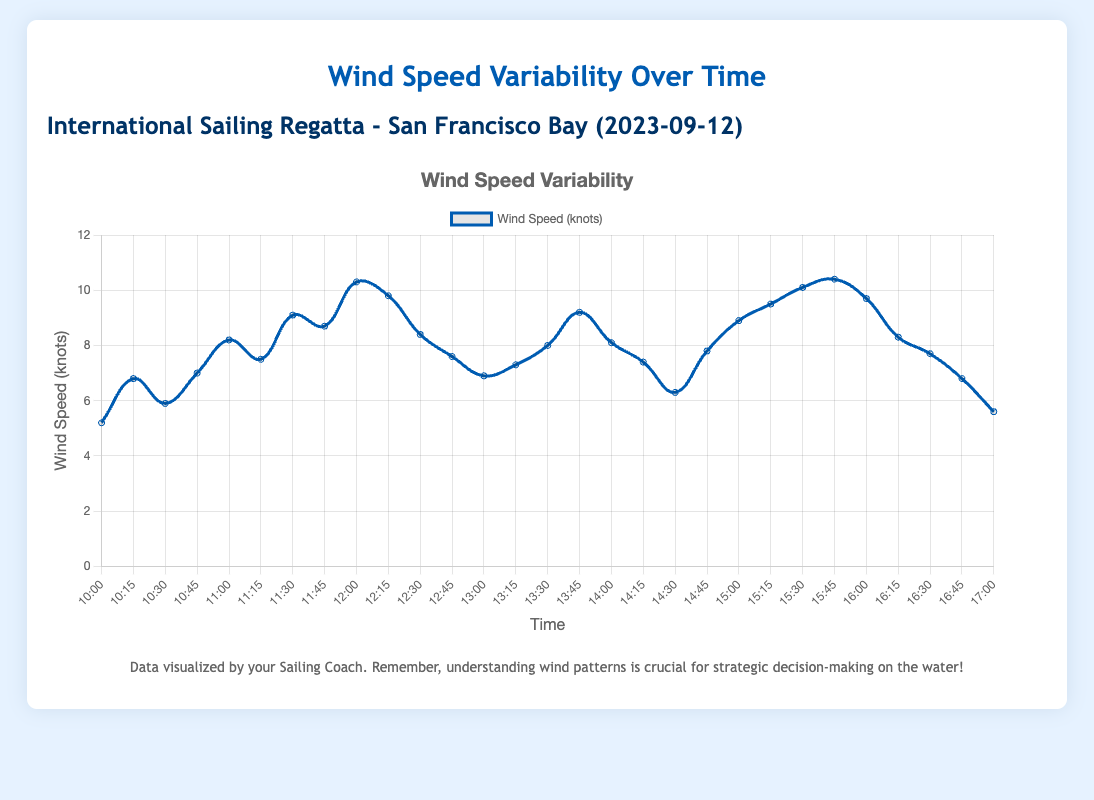What is the average wind speed between 14:00 and 15:00? To find the average wind speed between 14:00 and 15:00, add the wind speeds at 14:00, 14:15, 14:30, 14:45, and 15:00, then divide by the number of measurements. (8.1 + 7.4 + 6.3 + 7.8 + 8.9) / 5 = 38.5 / 5 = 7.7 knots
Answer: 7.7 knots At what time did the wind speed peak, and what was the value? Inspect the plot and identify the highest data point. The peak wind speed occurred at 15:45 with a value of 10.4 knots.
Answer: 15:45, 10.4 knots Which 30-minute interval showed the highest increase in wind speed? Look at consecutive 30-minute intervals and calculate the differences in wind speed. The highest increase is from 11:30 (9.1 knots) to 12:00 (10.3 knots), a change of 10.3 - 9.1 = 1.2 knots.
Answer: 11:30-12:00 What was the wind speed trend between 10:00 and 12:00? Observe the plot from 10:00 to 12:00. The wind speed generally increases from 5.2 knots to 10.3 knots.
Answer: Increasing How many times did the wind speed exceed 9.0 knots? Count the data points where wind speed is more than 9.0 knots at each time interval: 10:3, 11:30, 15:0, 15:15, 15:30, 15:45, summing up to 6 times.
Answer: 6 Compare the wind speeds at 11:00 and 17:00. Which one is higher, and by how much? The wind speed at 11:00 is 8.2 knots, and at 17:00 it is 5.6 knots. The difference is 8.2 - 5.6 = 2.6 knots. So, 11:00 is higher by 2.6 knots.
Answer: 11:00 is higher, 2.6 knots Was there any time when the wind speed was exactly 7.0 knots? If so, when? Check the plot for any instances of 7.0 knots. This happened at 10:45.
Answer: Yes, 10:45 What is the total change in wind speed from 10:00 to 17:00? Calculate the difference between the wind speed at 10:00 (5.2 knots) and the wind speed at 17:00 (5.6 knots). The total change is 5.6 - 5.2 = -0.4 knots.
Answer: -0.4 knots Identify the period with the most stable wind speed (least variability). Analyze the plot segments for the flattest slope. Between 14:00 and 14:15, wind speed changes almost minimally from 8.1 to 7.4 knots, showing stability.
Answer: 14:00-14:15 What is the median wind speed from the data set? First, order all wind speed values, find the middle value. Here the ordered values are: [5.2, 5.6, 5.9, 6.3, 6.8, 6.8, 6.9, 7.0, 7.3, 7.4, 7.5, 7.6, 7.7, 7.8, 8.0, 8.1, 8.2, 8.3, 8.4, 8.7, 8.9, 9.1, 9.2, 9.5, 9.7, 9.8, 10.1, 10.3, 10.4], the middle value (15th term) is 7.8.
Answer: 7.8 knots 